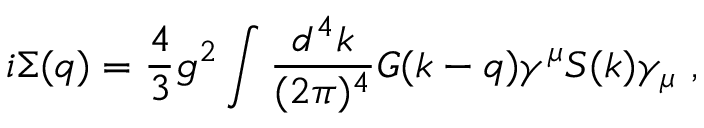<formula> <loc_0><loc_0><loc_500><loc_500>i \Sigma ( q ) = { \frac { 4 } { 3 } } { g ^ { 2 } } \int { \frac { d ^ { 4 } k } { ( 2 \pi ) ^ { 4 } } } G ( k - q ) \gamma ^ { \mu } S ( k ) \gamma _ { \mu } ,</formula> 